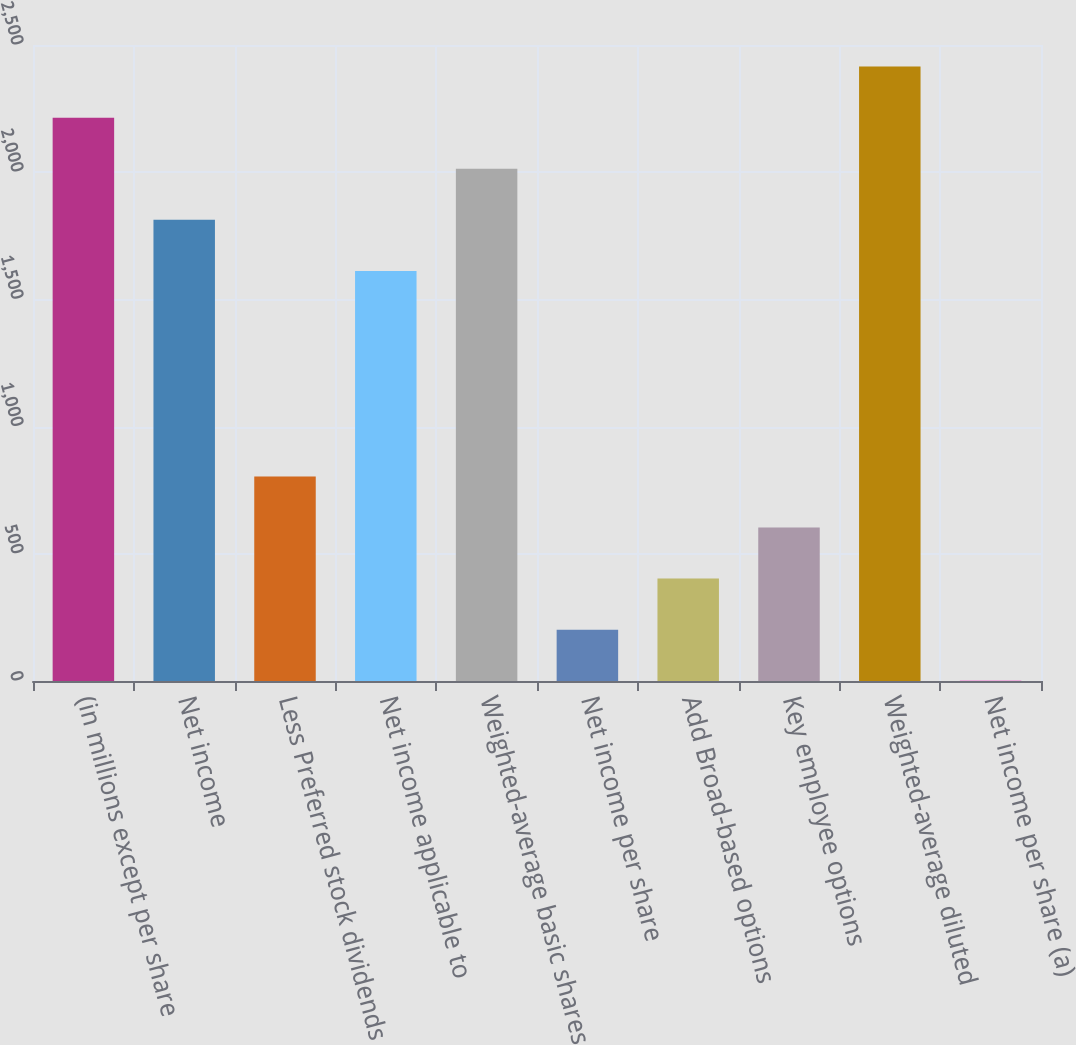<chart> <loc_0><loc_0><loc_500><loc_500><bar_chart><fcel>(in millions except per share<fcel>Net income<fcel>Less Preferred stock dividends<fcel>Net income applicable to<fcel>Weighted-average basic shares<fcel>Net income per share<fcel>Add Broad-based options<fcel>Key employee options<fcel>Weighted-average diluted<fcel>Net income per share (a)<nl><fcel>2214.49<fcel>1812.83<fcel>804.12<fcel>1612<fcel>2013.66<fcel>201.63<fcel>402.46<fcel>603.29<fcel>2415.32<fcel>0.8<nl></chart> 